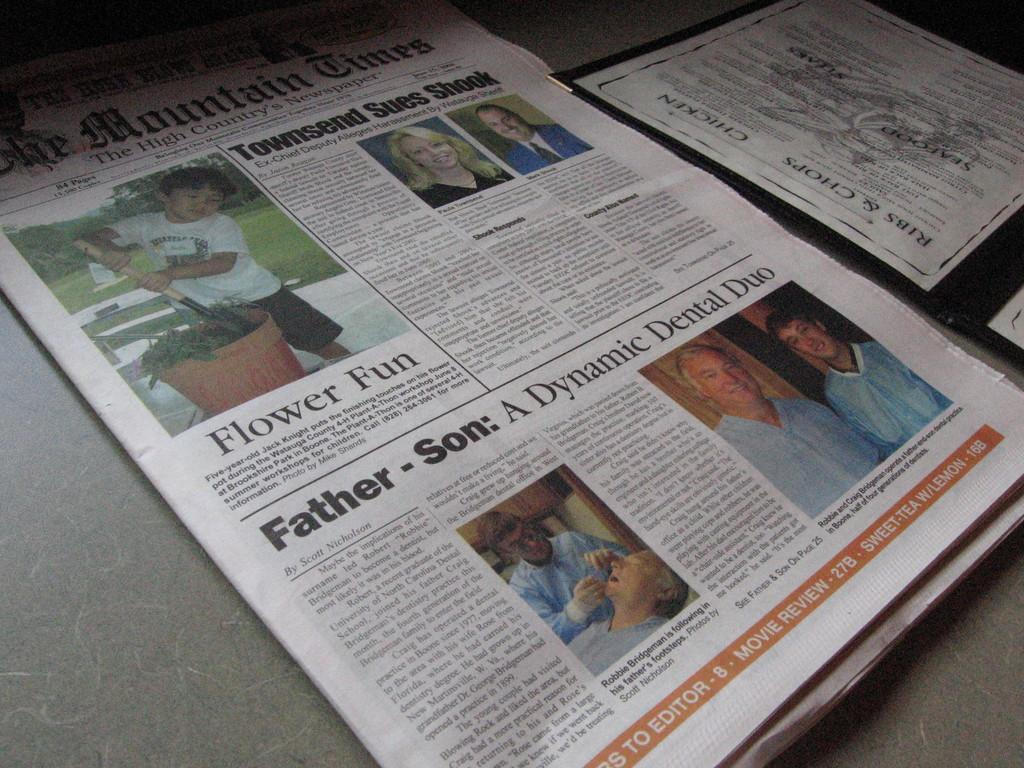<image>
Offer a succinct explanation of the picture presented. A copy of the Mountain Times newspaper laying on a table. 